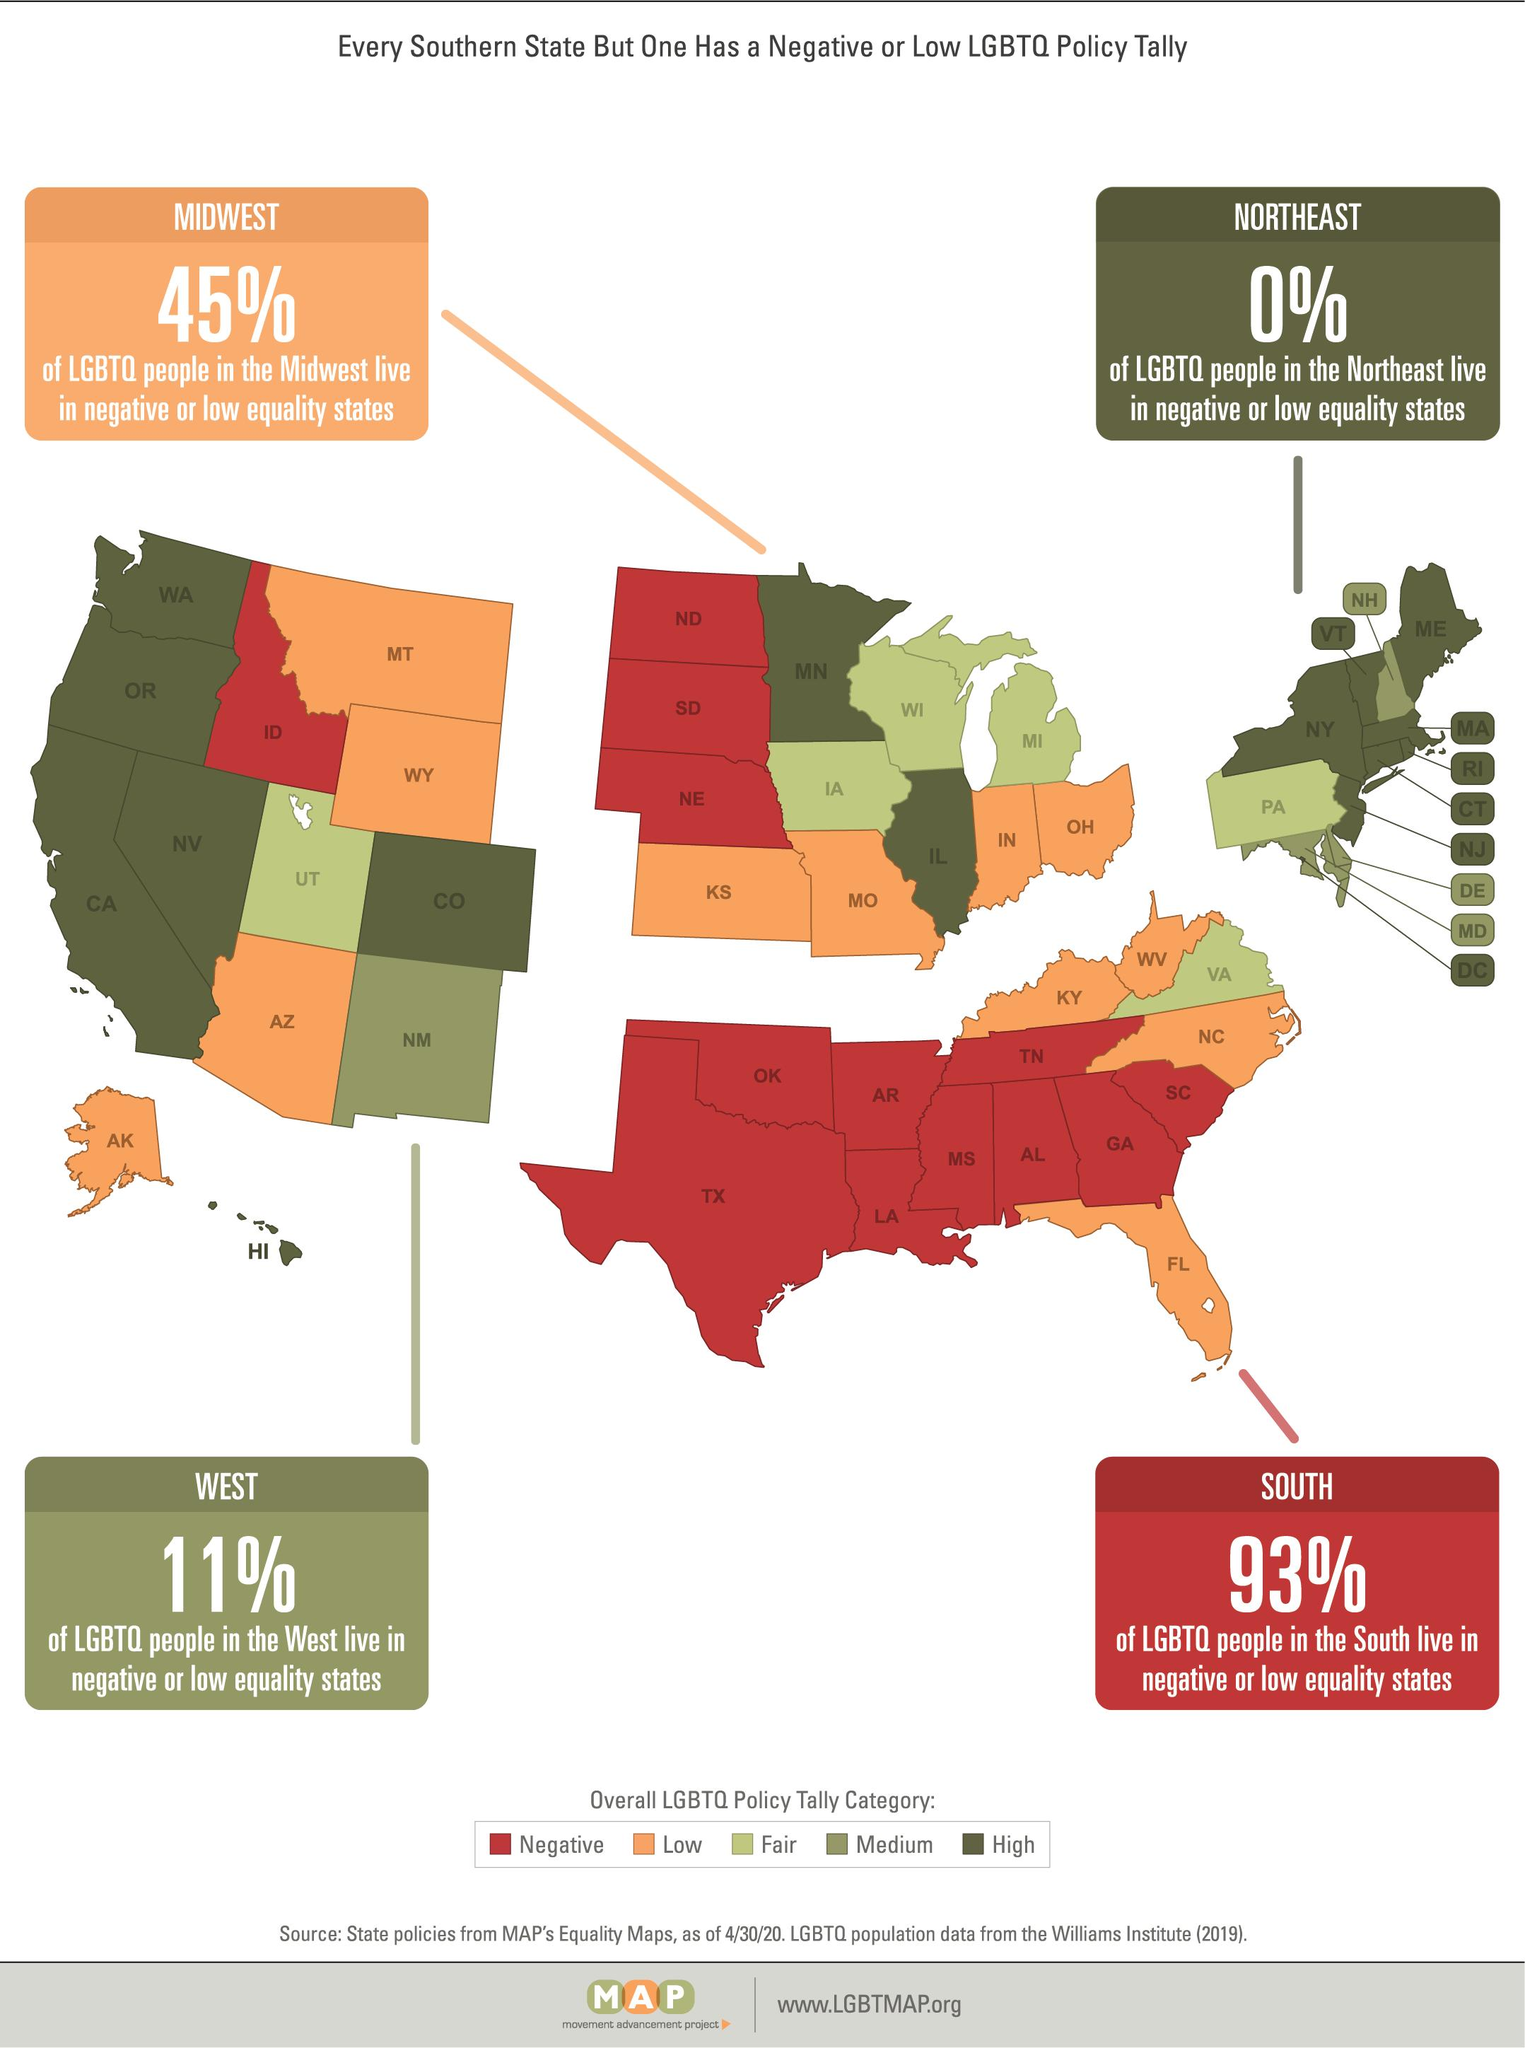Highlight a few significant elements in this photo. According to a recent survey, approximately 45% of people living in the Midwest reside in states with low or negative equality. There are 6 states that belong to Fair LGBTQ. According to a recent study, 89% of LGBTQ individuals living in West states do not reside in areas with low or negative equality. There are four states that have a Medium LGBTQ Policy Tally. According to the data, not a single person in the Northeast region of the United States resides in a state with negative or low equality. 